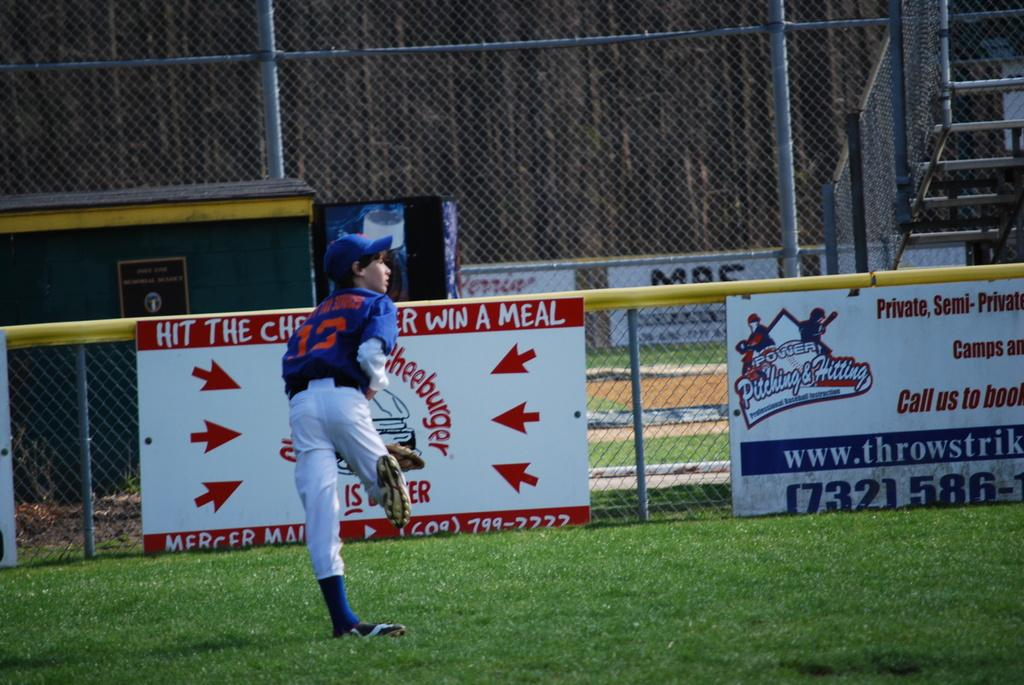Who is present in the image? There is a boy in the image. What is the boy standing on? The boy is standing on grassy land. What can be seen in the background of the image? There are banners, a fence, a board, a mesh, and stairs in the background of the image. What type of waste can be seen in the image? There is no waste present in the image. What punishment is the boy receiving in the image? There is no indication of punishment in the image; the boy is simply standing on grassy land. 